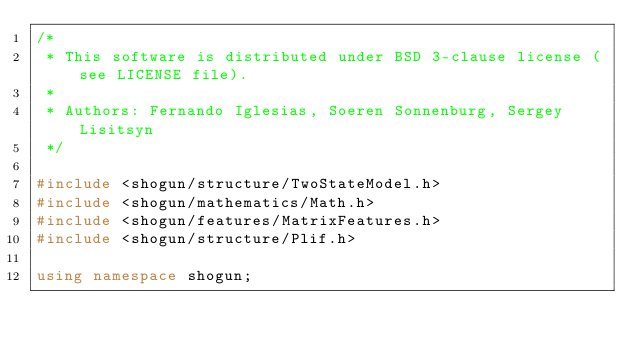Convert code to text. <code><loc_0><loc_0><loc_500><loc_500><_C++_>/*
 * This software is distributed under BSD 3-clause license (see LICENSE file).
 *
 * Authors: Fernando Iglesias, Soeren Sonnenburg, Sergey Lisitsyn
 */

#include <shogun/structure/TwoStateModel.h>
#include <shogun/mathematics/Math.h>
#include <shogun/features/MatrixFeatures.h>
#include <shogun/structure/Plif.h>

using namespace shogun;
</code> 